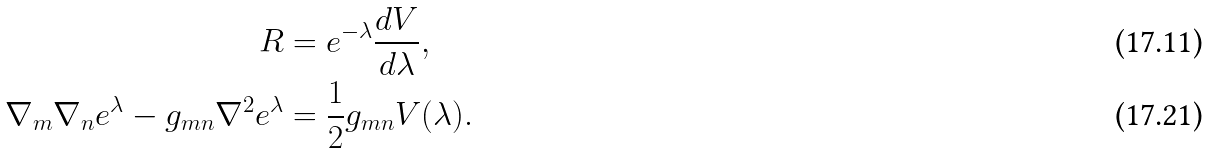<formula> <loc_0><loc_0><loc_500><loc_500>R & = e ^ { - \lambda } \frac { d V } { d \lambda } , \\ \nabla _ { m } \nabla _ { n } e ^ { \lambda } - g _ { m n } \nabla ^ { 2 } e ^ { \lambda } & = \frac { 1 } { 2 } g _ { m n } V ( \lambda ) .</formula> 